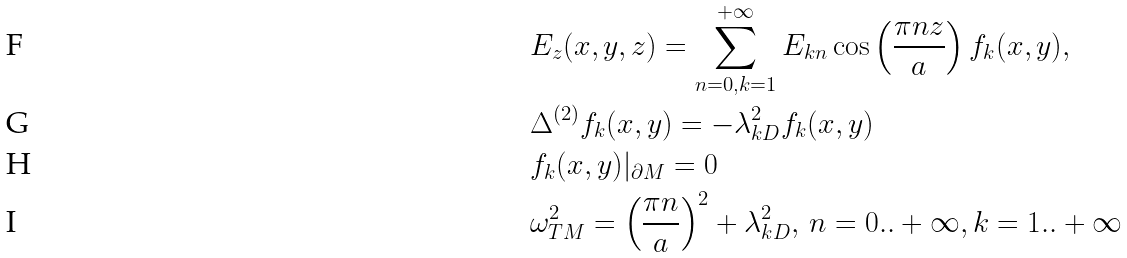<formula> <loc_0><loc_0><loc_500><loc_500>& E _ { z } ( x , y , z ) = \sum _ { n = 0 , k = 1 } ^ { + \infty } E _ { k n } \cos \left ( \frac { \pi n z } { a } \right ) f _ { k } ( x , y ) , \\ & \Delta ^ { ( 2 ) } f _ { k } ( x , y ) = - \lambda _ { k D } ^ { 2 } f _ { k } ( x , y ) \\ & f _ { k } ( x , y ) | _ { \partial M } = 0 \\ & \omega _ { T M } ^ { 2 } = \left ( \frac { \pi n } { a } \right ) ^ { 2 } + \lambda _ { k D } ^ { 2 } , \, n = 0 . . + \infty , k = 1 . . + \infty</formula> 